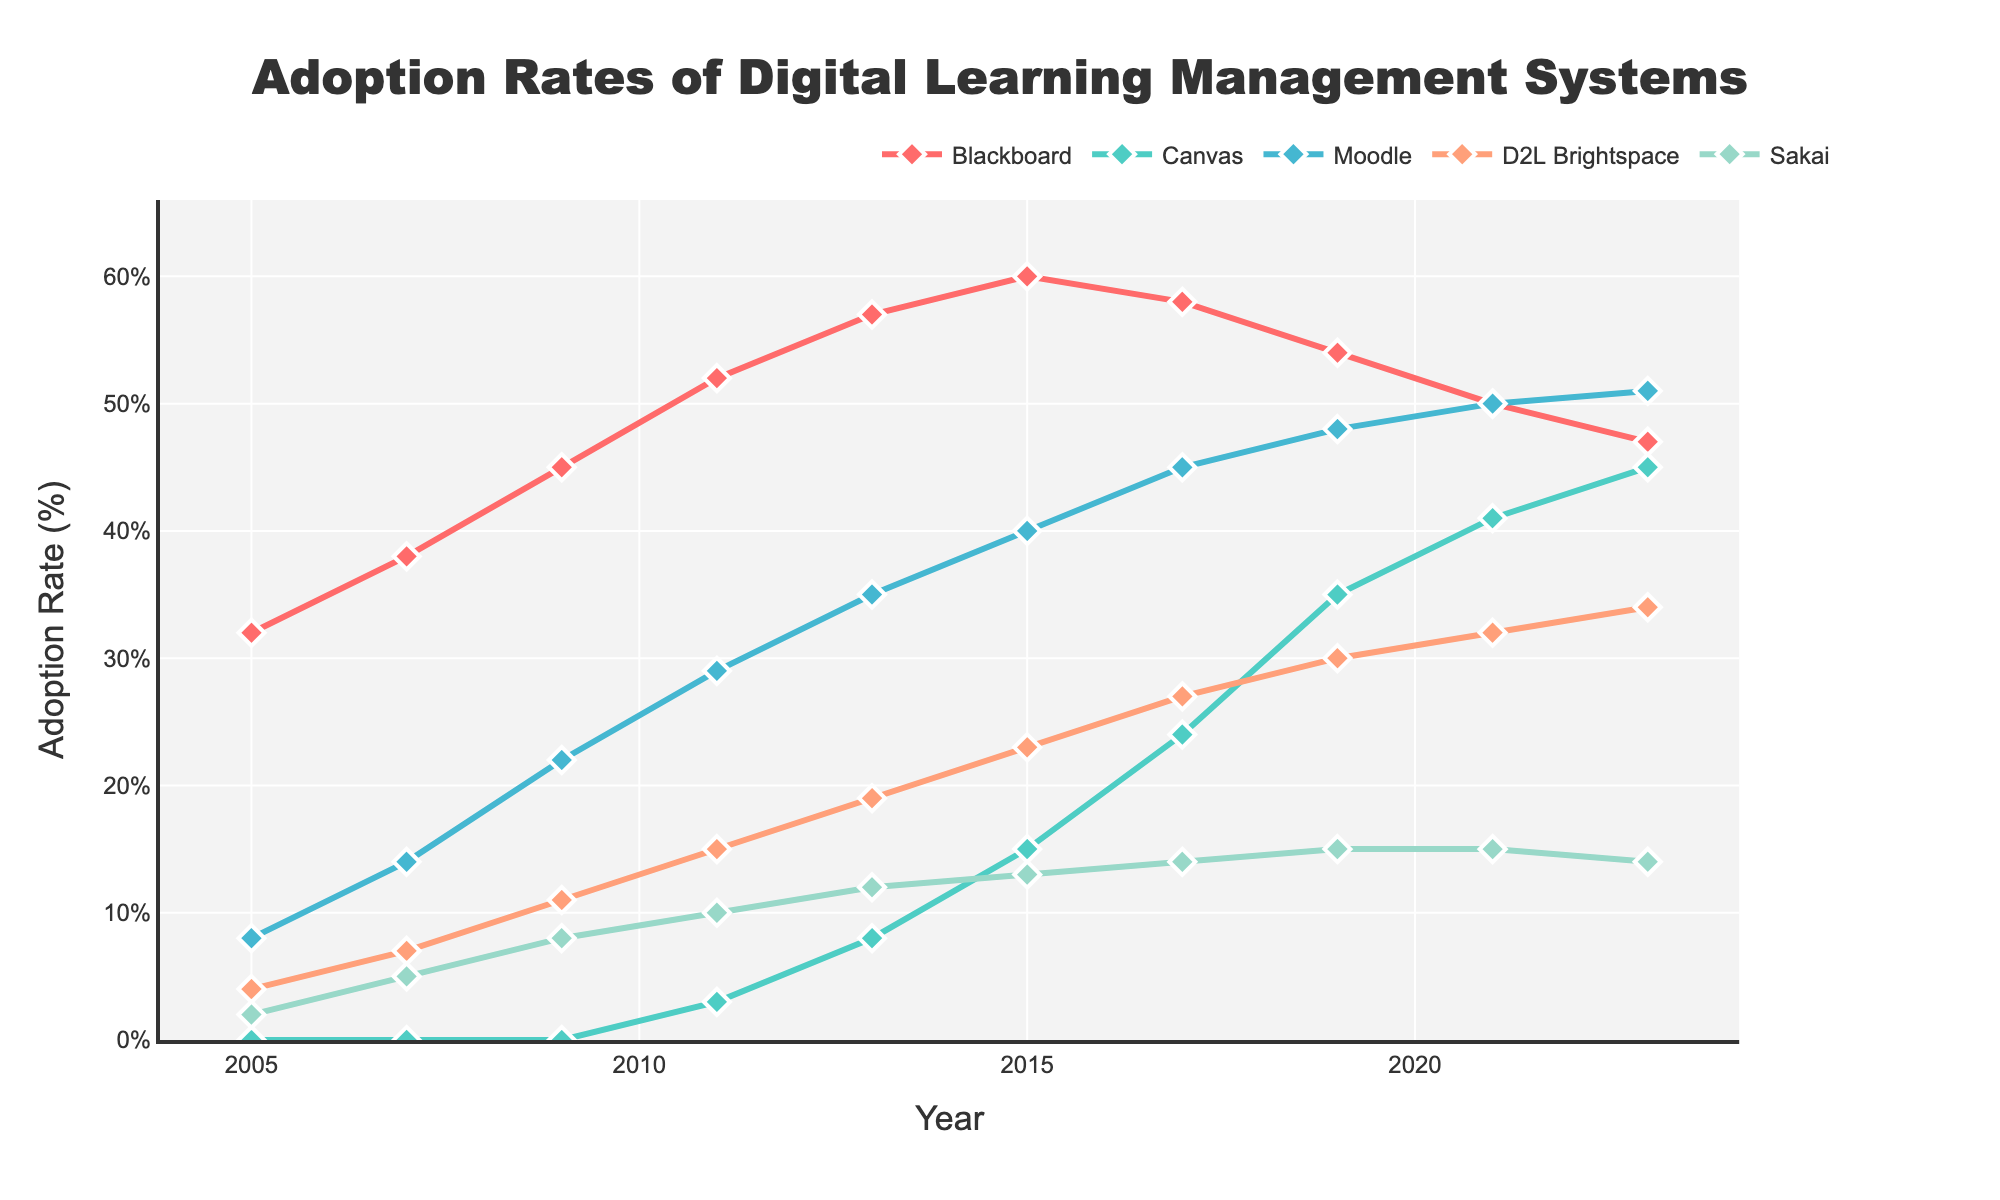what's the difference in adoption rates of Blackboard between 2005 and 2023? To find the difference in adoption rates of Blackboard between 2005 and 2023, subtract the 2023 rate from the 2005 rate: 47% (2023) - 32% (2005) = 15%
Answer: 15% which system had the highest adoption increase from 2005 to 2023? Examine the adoption rates of all systems between 2005 and 2023. Canvas increased from 0% to 45%, a 45% increase, which is the highest among all systems.
Answer: Canvas which learning management system was adopted at the fastest rate from 2011 to 2017? By examining the rates between 2011 and 2017, Canvas increases from 3% to 24%, which is the highest rate of increase (21%) in this period.
Answer: Canvas how many systems had an adoption rate of 15% or higher in 2015? Looking at 2015 data, three systems have an adoption rate of 15% or higher: Blackboard (60%), Moodle (40%), and D2L Brightspace (23%).
Answer: 3 which systems had reduced adoption rates from 2015 to 2021? Compare the adoption rates from 2015 to 2021 for each system. Blackboard decreased from 60% to 50%, and Sakai decreased from 13% to 15%.
Answer: Blackboard and Sakai what was the average adoption rate of Canvas over the period from 2013 to 2023? The adoption rates for Canvas over the period from 2013 to 2023 are 8%, 15%, 24%, 35%, 41%, 45%. Sum these values: 8+15+24+35+41+45 = 168. To find the average: 168/6 = 28
Answer: 28% which system has the consistently highest adoption rate every year? Compare the adoption rates of each system in each year from 2005 to 2023. Blackboard consistently has the highest adoption rate every year.
Answer: Blackboard which system shows the least variation in adoption rates from 2005 to 2023? Calculate the range of adoption rates (highest - lowest) for each system. Sakai varies from 2% to 15%, a range of 13%, which is the least variation.
Answer: Sakai 